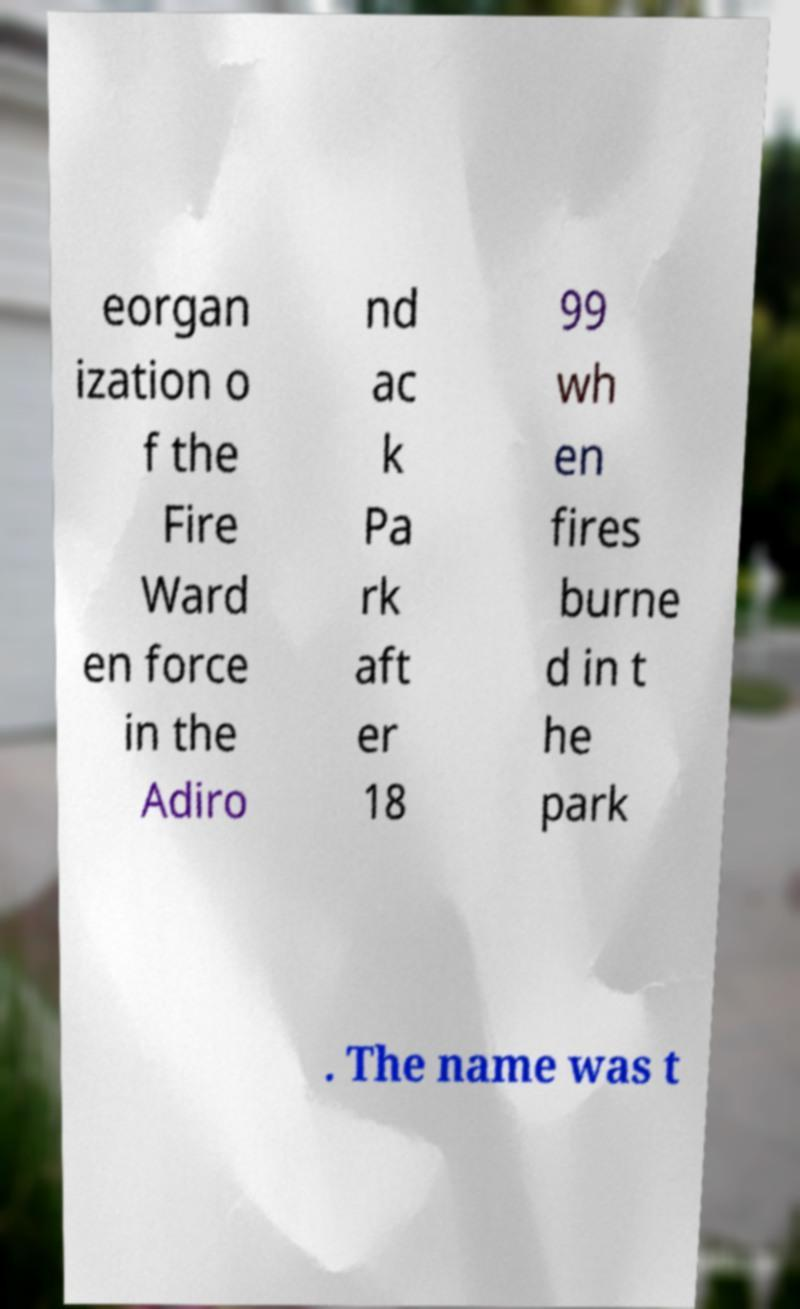Could you extract and type out the text from this image? eorgan ization o f the Fire Ward en force in the Adiro nd ac k Pa rk aft er 18 99 wh en fires burne d in t he park . The name was t 